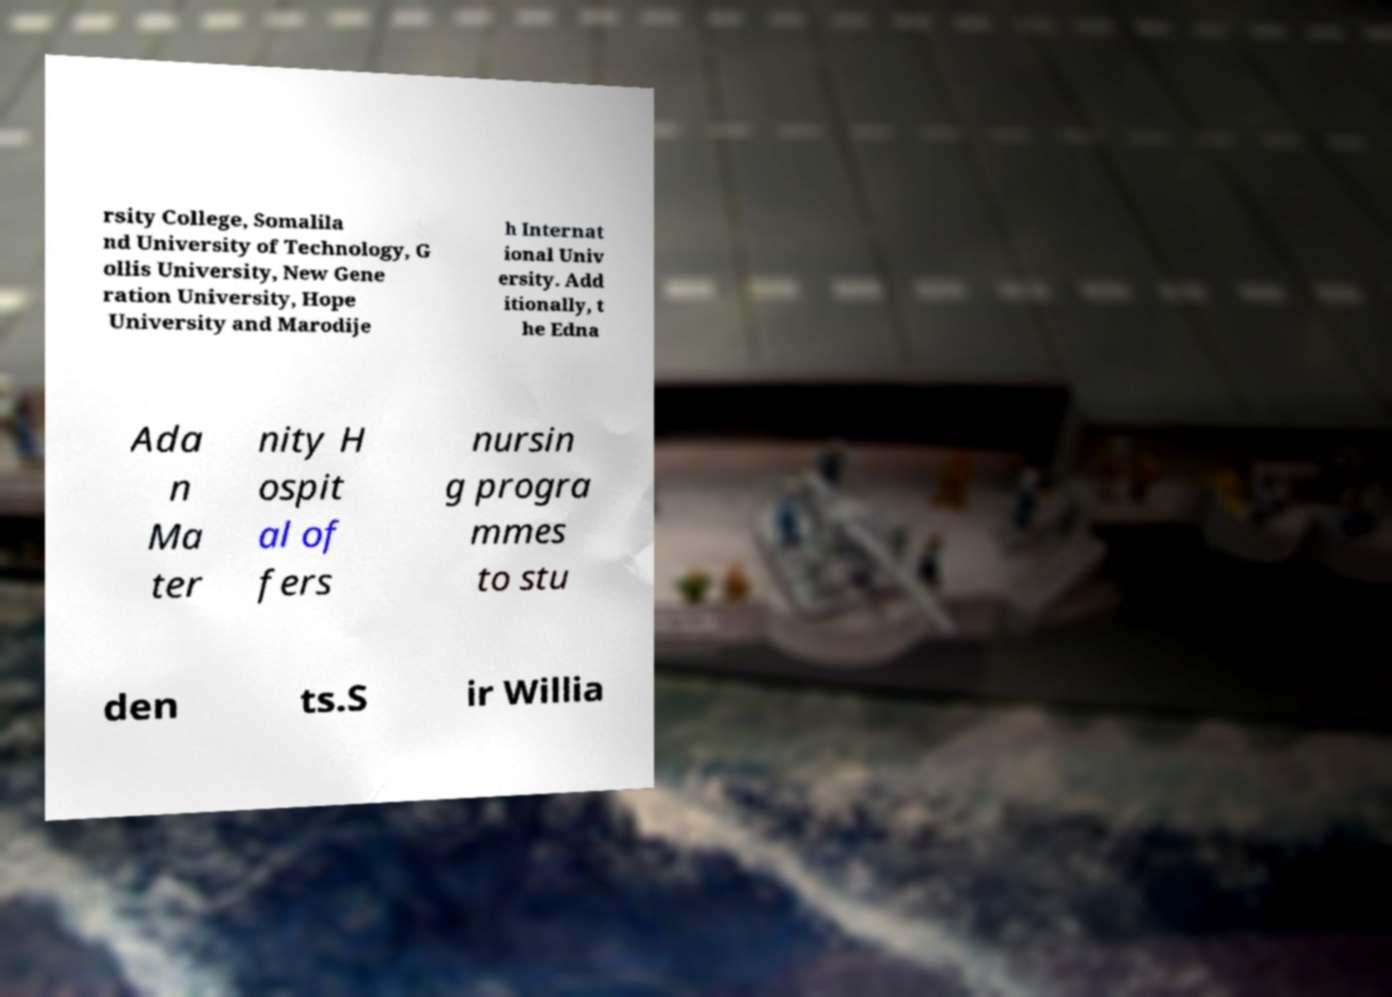What messages or text are displayed in this image? I need them in a readable, typed format. rsity College, Somalila nd University of Technology, G ollis University, New Gene ration University, Hope University and Marodije h Internat ional Univ ersity. Add itionally, t he Edna Ada n Ma ter nity H ospit al of fers nursin g progra mmes to stu den ts.S ir Willia 